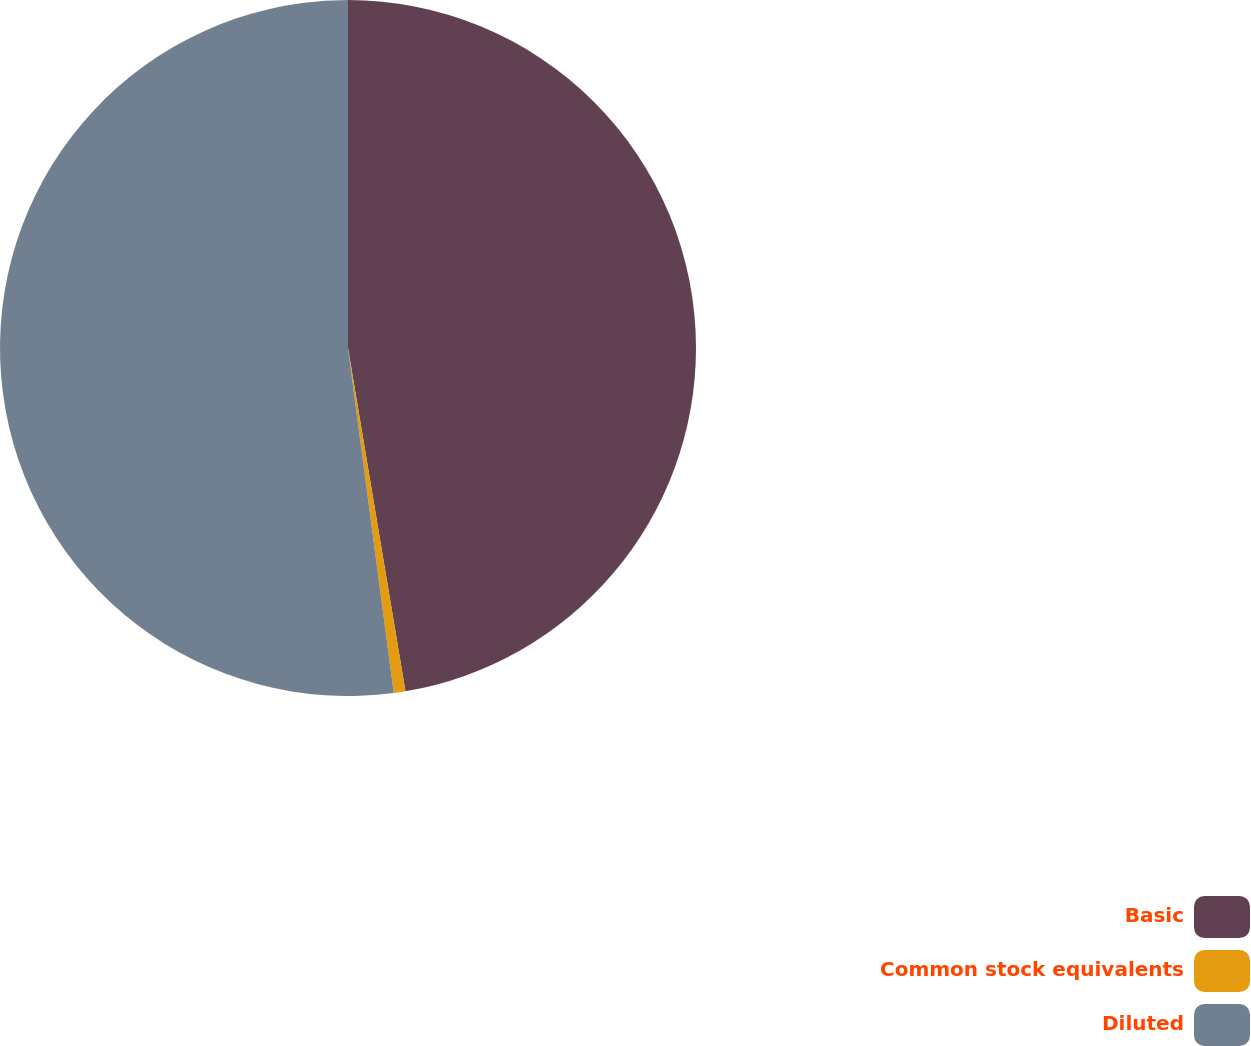<chart> <loc_0><loc_0><loc_500><loc_500><pie_chart><fcel>Basic<fcel>Common stock equivalents<fcel>Diluted<nl><fcel>47.36%<fcel>0.54%<fcel>52.1%<nl></chart> 